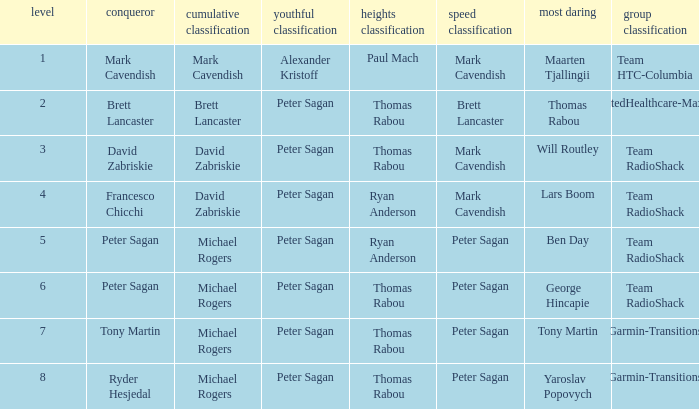When Brett Lancaster won the general classification, who won the team calssification? UnitedHealthcare-Maxxis. 